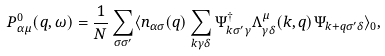<formula> <loc_0><loc_0><loc_500><loc_500>P _ { \alpha \mu } ^ { 0 } ( q , \omega ) = \frac { 1 } { N } \sum _ { \sigma \sigma ^ { \prime } } \langle n _ { \alpha \sigma } ( q ) \sum _ { k \gamma \delta } \Psi _ { k \sigma ^ { \prime } \gamma } ^ { \dag } \Lambda _ { \gamma \delta } ^ { \mu } ( k , q ) \Psi _ { k + q \sigma ^ { \prime } \delta } \rangle _ { 0 } ,</formula> 